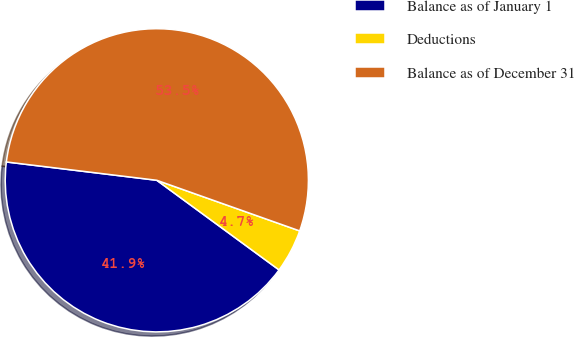<chart> <loc_0><loc_0><loc_500><loc_500><pie_chart><fcel>Balance as of January 1<fcel>Deductions<fcel>Balance as of December 31<nl><fcel>41.86%<fcel>4.65%<fcel>53.49%<nl></chart> 